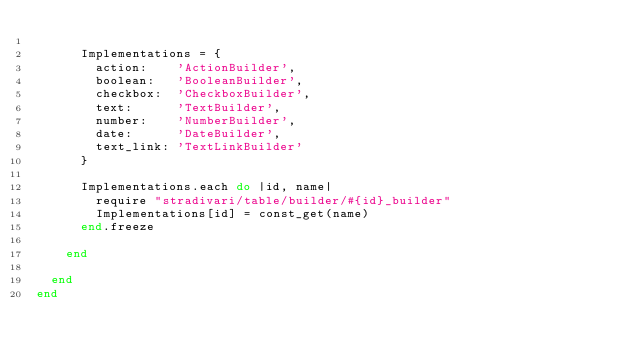<code> <loc_0><loc_0><loc_500><loc_500><_Ruby_>
      Implementations = {
        action:    'ActionBuilder',
        boolean:   'BooleanBuilder',
        checkbox:  'CheckboxBuilder',
        text:      'TextBuilder',
        number:    'NumberBuilder',
        date:      'DateBuilder',
        text_link: 'TextLinkBuilder'
      }

      Implementations.each do |id, name|
        require "stradivari/table/builder/#{id}_builder"
        Implementations[id] = const_get(name)
      end.freeze

    end

  end
end
</code> 